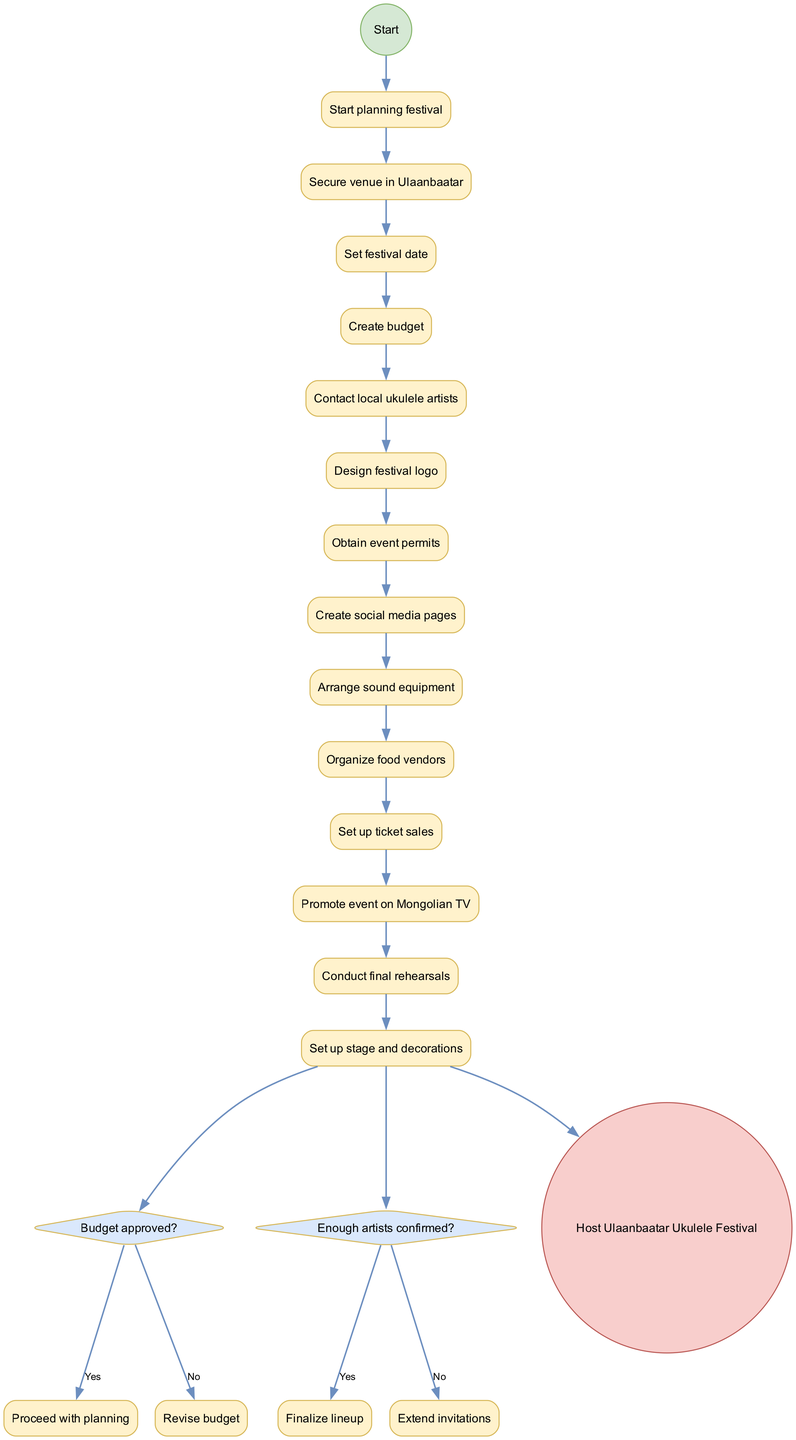What is the first activity listed in the diagram? The diagram shows the activities in the order they should be completed. The first activity after "Start planning festival" is "Secure venue in Ulaanbaatar."
Answer: Secure venue in Ulaanbaatar How many decision points are shown in the diagram? The diagram contains two decision points represented by diamond shapes. These decisions relate to budget approval and the confirmation of artists.
Answer: 2 What happens if the budget is not approved? According to the decision “Budget approved?”, if the answer is "No," the flow goes to "Revise budget." This indicates that the planning will need to be adjusted.
Answer: Revise budget What is the last activity before hosting the festival? The final activity before reaching the last node, "Host Ulaanbaatar Ukulele Festival," is "Conduct final rehearsals." This is a crucial step immediately preceding the event.
Answer: Conduct final rehearsals What condition must be fulfilled to proceed with the planning? The decision labeled "Budget approved?" must be met positively. If it is approved, then the planning can continue without revisions.
Answer: Budget approved What is the final node in the diagram? The last node, representing the conclusion of the planning and execution process, is "Host Ulaanbaatar Ukulele Festival." This signifies the successful completion of the festival organization.
Answer: Host Ulaanbaatar Ukulele Festival Which activity helps secure the festival's budget? The diagram lists "Create budget" as the related activity that would determine the financial aspect of the festival's organization, helping to secure funds before moving on.
Answer: Create budget What are the steps to extend artist invitations if not enough are confirmed? The decision point for "Enough artists confirmed?" leads to "Extend invitations" if the answer is "No," allowing for more outreach to fulfill this requirement.
Answer: Extend invitations 